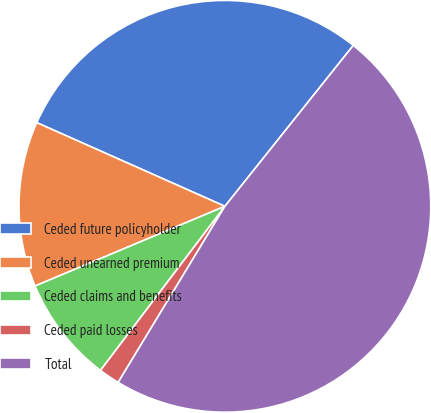Convert chart. <chart><loc_0><loc_0><loc_500><loc_500><pie_chart><fcel>Ceded future policyholder<fcel>Ceded unearned premium<fcel>Ceded claims and benefits<fcel>Ceded paid losses<fcel>Total<nl><fcel>29.06%<fcel>12.99%<fcel>8.35%<fcel>1.65%<fcel>47.96%<nl></chart> 